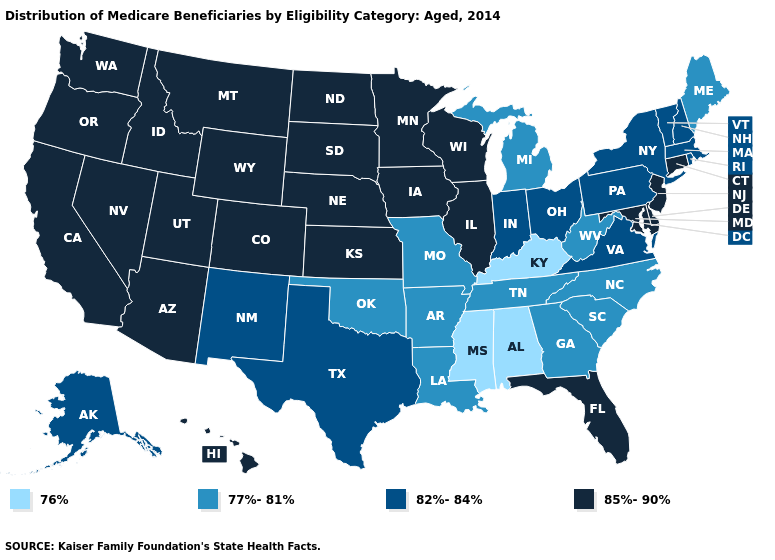What is the value of Mississippi?
Short answer required. 76%. What is the value of South Dakota?
Answer briefly. 85%-90%. Name the states that have a value in the range 85%-90%?
Concise answer only. Arizona, California, Colorado, Connecticut, Delaware, Florida, Hawaii, Idaho, Illinois, Iowa, Kansas, Maryland, Minnesota, Montana, Nebraska, Nevada, New Jersey, North Dakota, Oregon, South Dakota, Utah, Washington, Wisconsin, Wyoming. Does Ohio have the lowest value in the USA?
Concise answer only. No. Which states hav the highest value in the South?
Quick response, please. Delaware, Florida, Maryland. What is the value of Illinois?
Concise answer only. 85%-90%. What is the value of Iowa?
Concise answer only. 85%-90%. What is the value of Indiana?
Give a very brief answer. 82%-84%. Name the states that have a value in the range 82%-84%?
Concise answer only. Alaska, Indiana, Massachusetts, New Hampshire, New Mexico, New York, Ohio, Pennsylvania, Rhode Island, Texas, Vermont, Virginia. What is the value of Hawaii?
Short answer required. 85%-90%. Name the states that have a value in the range 82%-84%?
Concise answer only. Alaska, Indiana, Massachusetts, New Hampshire, New Mexico, New York, Ohio, Pennsylvania, Rhode Island, Texas, Vermont, Virginia. Does Montana have the highest value in the USA?
Keep it brief. Yes. Name the states that have a value in the range 77%-81%?
Be succinct. Arkansas, Georgia, Louisiana, Maine, Michigan, Missouri, North Carolina, Oklahoma, South Carolina, Tennessee, West Virginia. Among the states that border Delaware , which have the highest value?
Write a very short answer. Maryland, New Jersey. What is the value of Alaska?
Keep it brief. 82%-84%. 